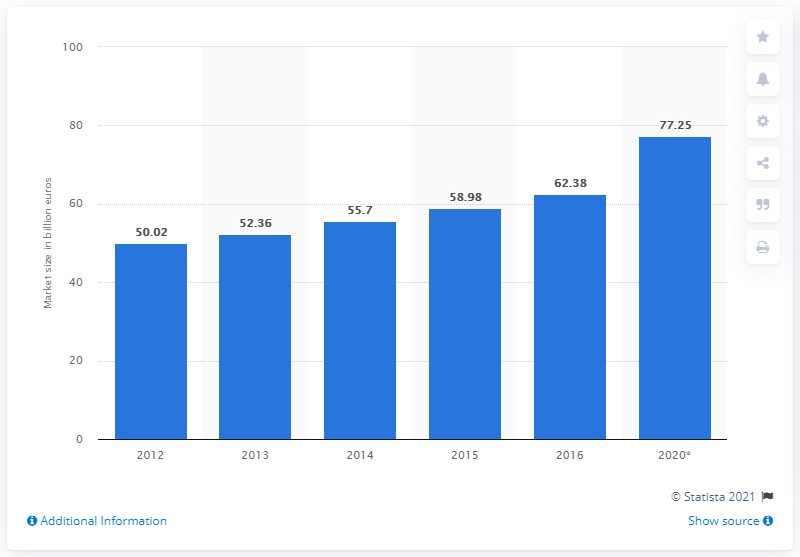Indicate a few pertinent items in this graphic. The European express and small parcels market was worth 62.38 billion euros in 2016. 